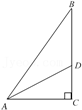What mathematical principles can be applied to study this triangle? This right triangle can be studied using the Pythagorean theorem, which relates the lengths of the sides of right triangles. Moreover, trigonometric ratios such as sine, cosine, and tangent can be used to investigate the angles and relationships between the different segments. 